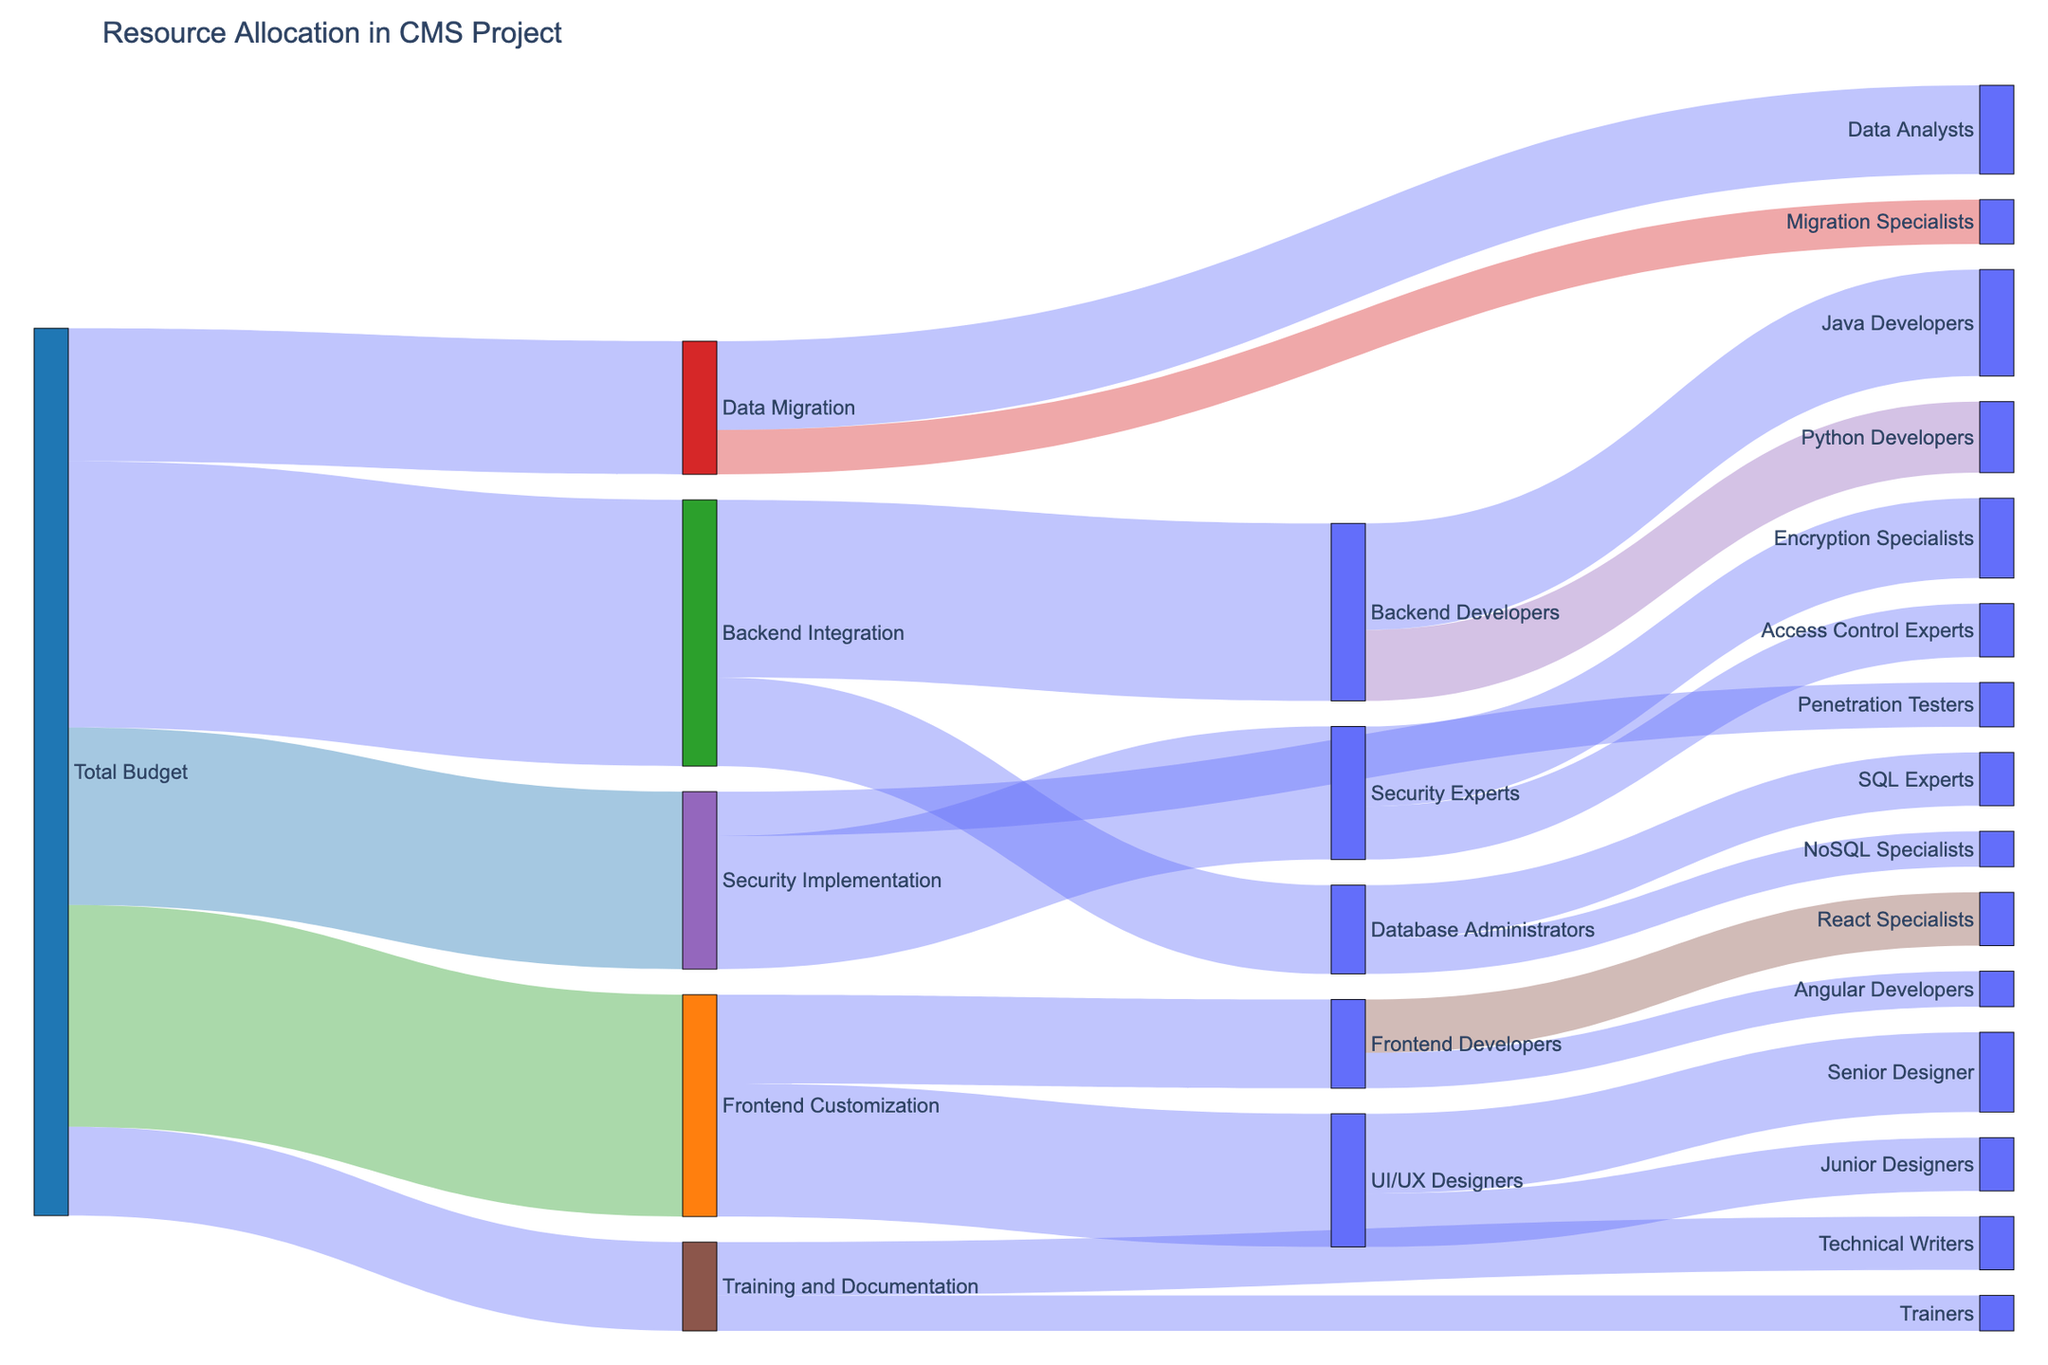What's the total budget allocation for all the customization components? To find the total budget allocation, sum up the values for all the customization components: Frontend Customization (250,000) + Backend Integration (300,000) + Data Migration (150,000) + Security Implementation (200,000) + Training and Documentation (100,000) = 1,000,000
Answer: 1,000,000 How much budget is allocated to Security Implementation compared to Data Migration? Compare the values directly: Security Implementation has 200,000 and Data Migration has 150,000, so Security Implementation has a higher budget allocation.
Answer: 50,000 more Which component has the least allocation from the total budget? By comparing the allocated budgets, Training and Documentation has the least allocation with 100,000.
Answer: Training and Documentation What is the combined budget for Backend Integration and Data Migration? Sum the budgets for Backend Integration (300,000) and Data Migration (150,000): 300,000 + 150,000 = 450,000
Answer: 450,000 Which personnel category under Frontend Customization has the higher allocation, UI/UX Designers or Frontend Developers? Compare the allocation values: UI/UX Designers (150,000) and Frontend Developers (100,000), so UI/UX Designers have the higher allocation.
Answer: UI/UX Designers What is the total budget allocated to personnel in Frontend Customization? Sum the budget allocations for UI/UX Designers (150,000) and Frontend Developers (100,000): 150,000 + 100,000 = 250,000
Answer: 250,000 How much budget is specifically allocated to Junior Designers within the project? Follow the node paths: Total Budget -> Frontend Customization -> UI/UX Designers -> Junior Designers, where Junior Designers receive 60,000.
Answer: 60,000 What is the difference in budget allocation between React Specialists and Angular Developers? Compare the values: React Specialists have 60,000 and Angular Developers have 40,000, so the difference is 60,000 - 40,000 = 20,000
Answer: 20,000 Which personnel category in Backend Integration has a higher budget allocation, Backend Developers or Database Administrators? Compare the allocation values: Backend Developers (200,000) and Database Administrators (100,000), so Backend Developers have the higher allocation.
Answer: Backend Developers How much more budget is allocated to Training and Documentation compared to Migration Specialists in Data Migration? Compare the budget allocations: Training and Documentation has 100,000 and Migration Specialists have 50,000: 100,000 - 50,000 = 50,000
Answer: 50,000 